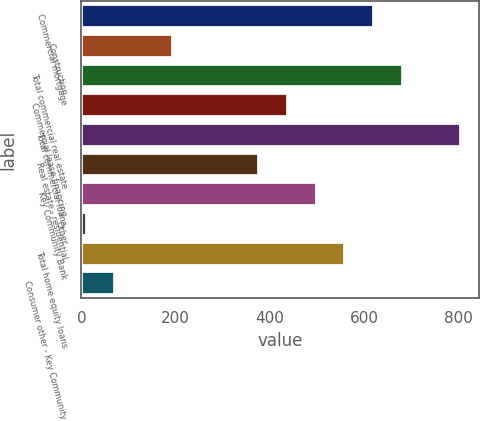Convert chart to OTSL. <chart><loc_0><loc_0><loc_500><loc_500><bar_chart><fcel>Commercial mortgage<fcel>Construction<fcel>Total commercial real estate<fcel>Commercial lease financing<fcel>Total commercial loans<fcel>Real estate - residential<fcel>Key Community Bank<fcel>Other<fcel>Total home equity loans<fcel>Consumer other - Key Community<nl><fcel>621<fcel>194<fcel>682<fcel>438<fcel>804<fcel>377<fcel>499<fcel>11<fcel>560<fcel>72<nl></chart> 